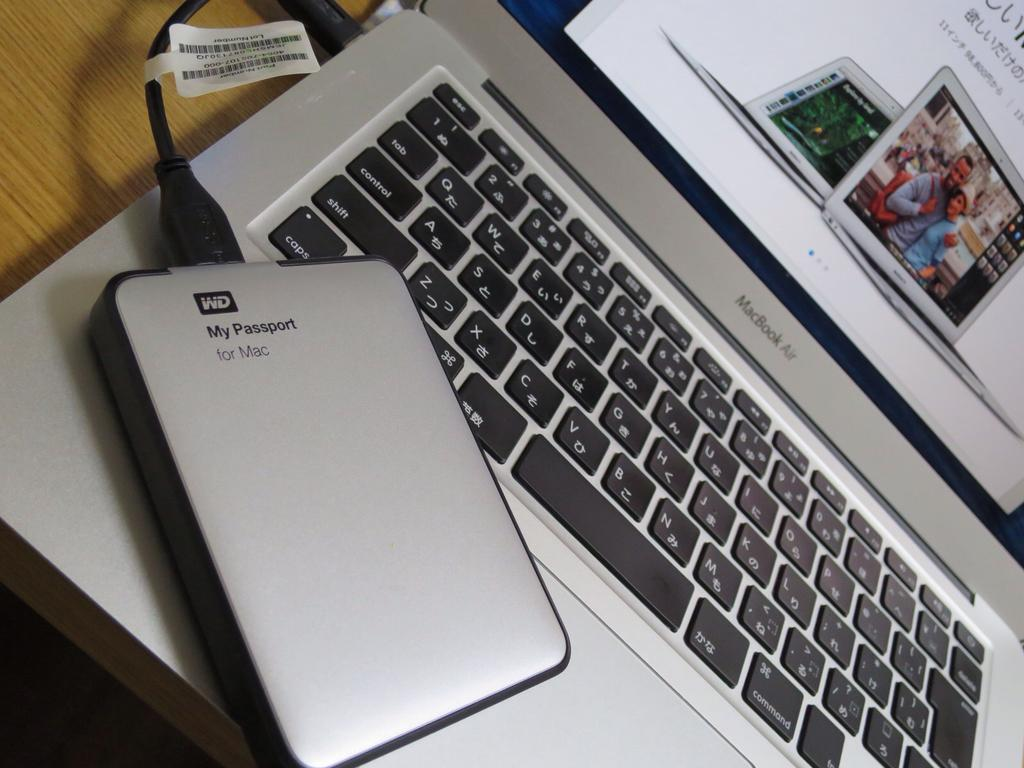<image>
Write a terse but informative summary of the picture. A WD My Passport for Mac device hooked up to a gray MacBook Air 